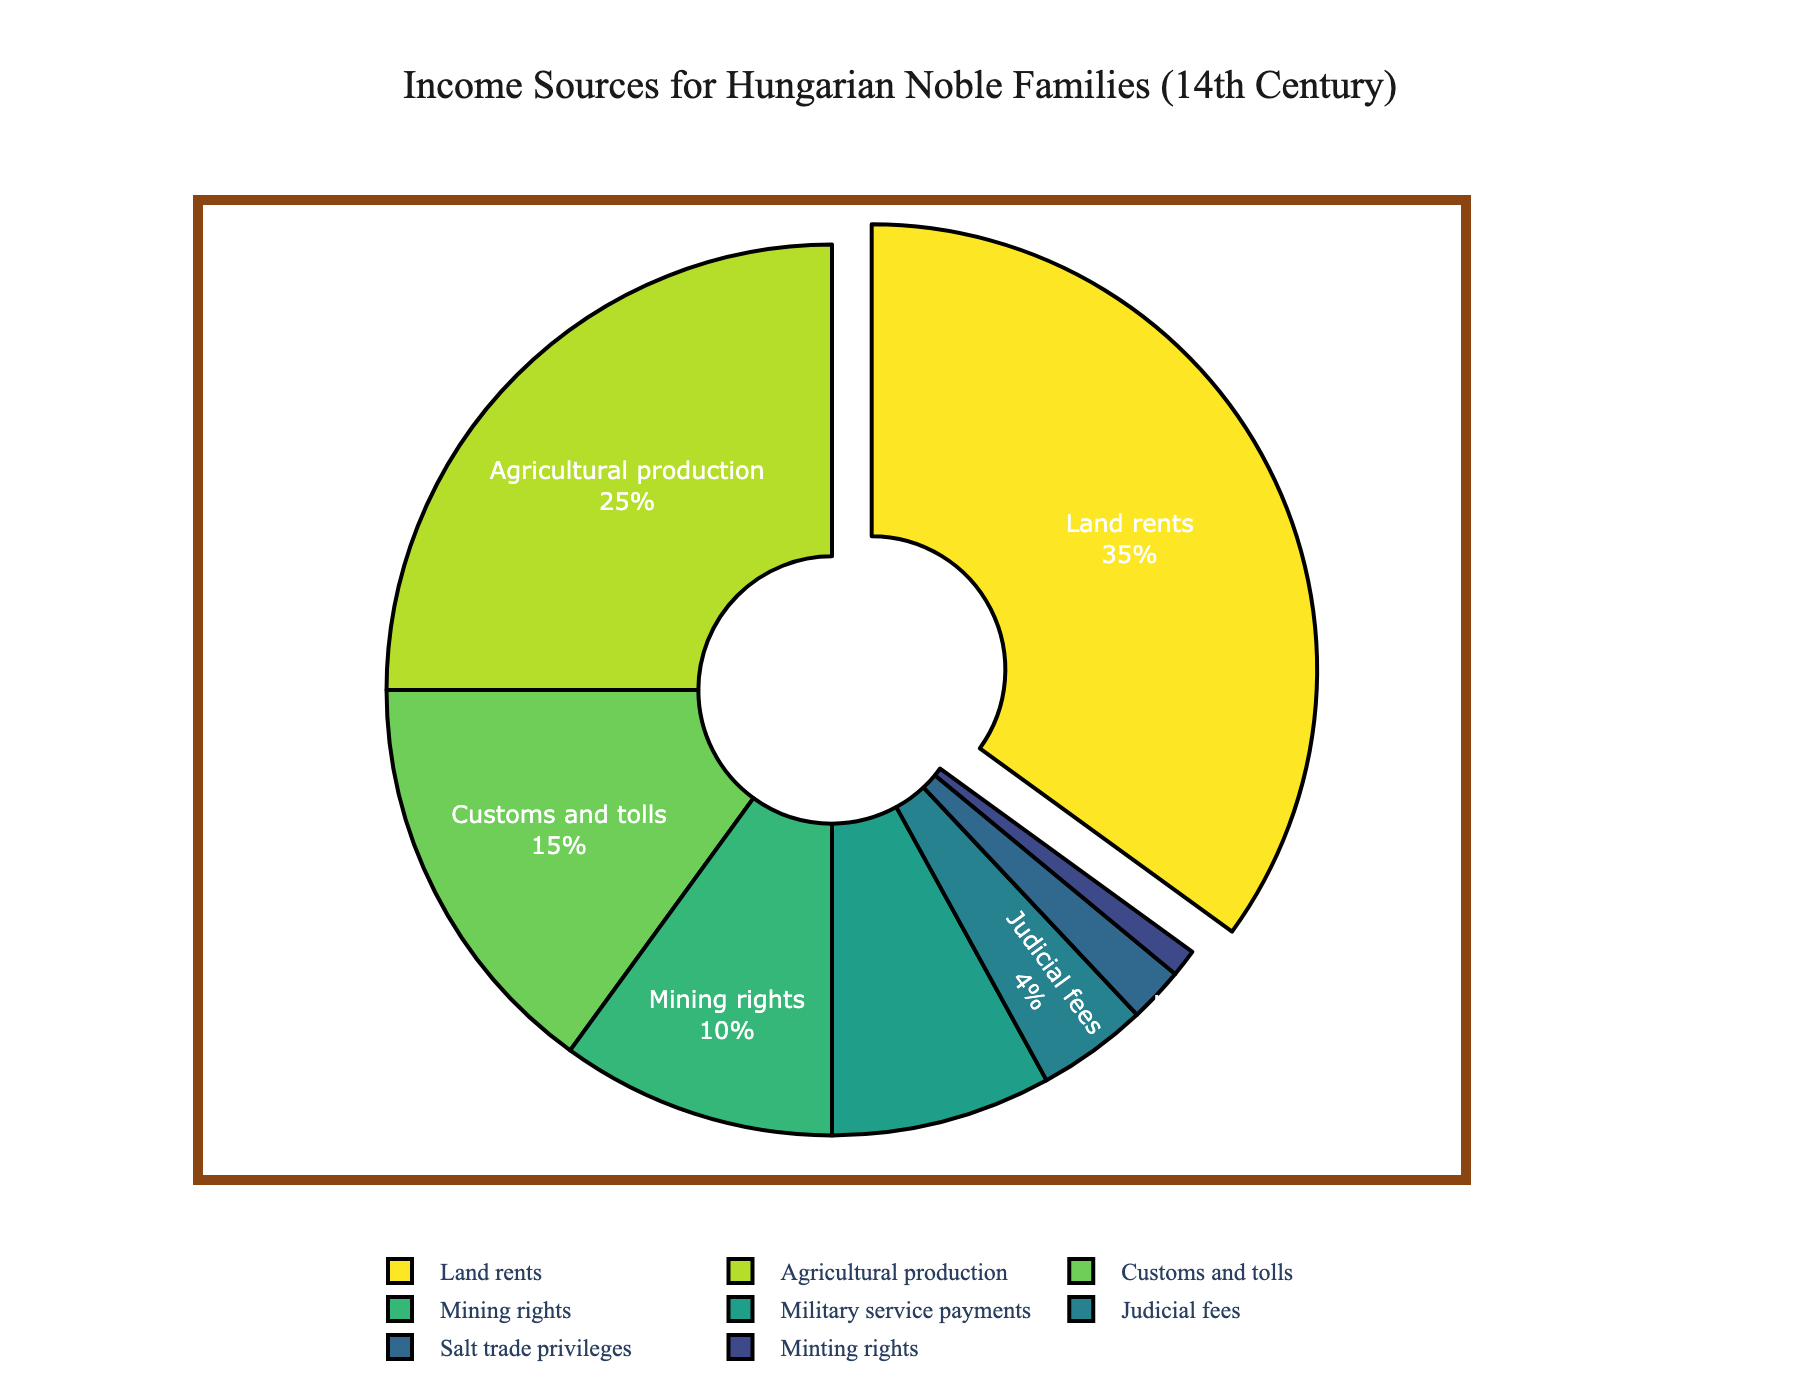What's the largest source of income for Hungarian noble families in the 14th century? The largest segment of the pie chart is pulled out, indicating it as the largest. This segment is labeled as "Land rents" and represents 35% of the income.
Answer: Land rents What percentage of income comes from mining rights and salt trade privileges combined? The chart shows Mining rights at 10% and Salt trade privileges at 2%. Adding these together: 10% + 2% = 12%.
Answer: 12% Which category contributes more to the income, customs and tolls or agricultural production? The chart shows percentages for Customs and tolls at 15% and Agricultural production at 25%. Since 25% is greater than 15%, Agricultural production contributes more.
Answer: Agricultural production Are the judicial fees a larger or smaller source of income compared to military service payments? Judicial fees are 4%, while Military service payments are 8%. Comparing these, 4% is smaller than 8%.
Answer: Smaller How much more do land rents contribute to the income compared to judicial fees? Land rents are 35% and judicial fees are 4%. The difference is 35% - 4% = 31%.
Answer: 31% What visual feature identifies the largest income source in the pie chart? The largest income source segment (Land rents) is visually pulled out from the rest of the pie chart.
Answer: Pulled out segment If mining rights and minting rights are combined, do they exceed customs and tolls in percentage? Mining rights are 10% and Minting rights are 1%. Combined, they are 10% + 1% = 11%, which is less than Customs and tolls at 15%.
Answer: No What is the sum of percentages for the three smallest sources of income? The three smallest sources are Minting rights (1%), Salt trade privileges (2%), and Judicial fees (4%). Adding these: 1% + 2% + 4% = 7%.
Answer: 7% Among the sources listed, which one is the third largest contributor to the income? The third largest contributor (sorted by percentage) would be Customs and tolls at 15%, after Land rents and Agricultural production.
Answer: Customs and tolls 